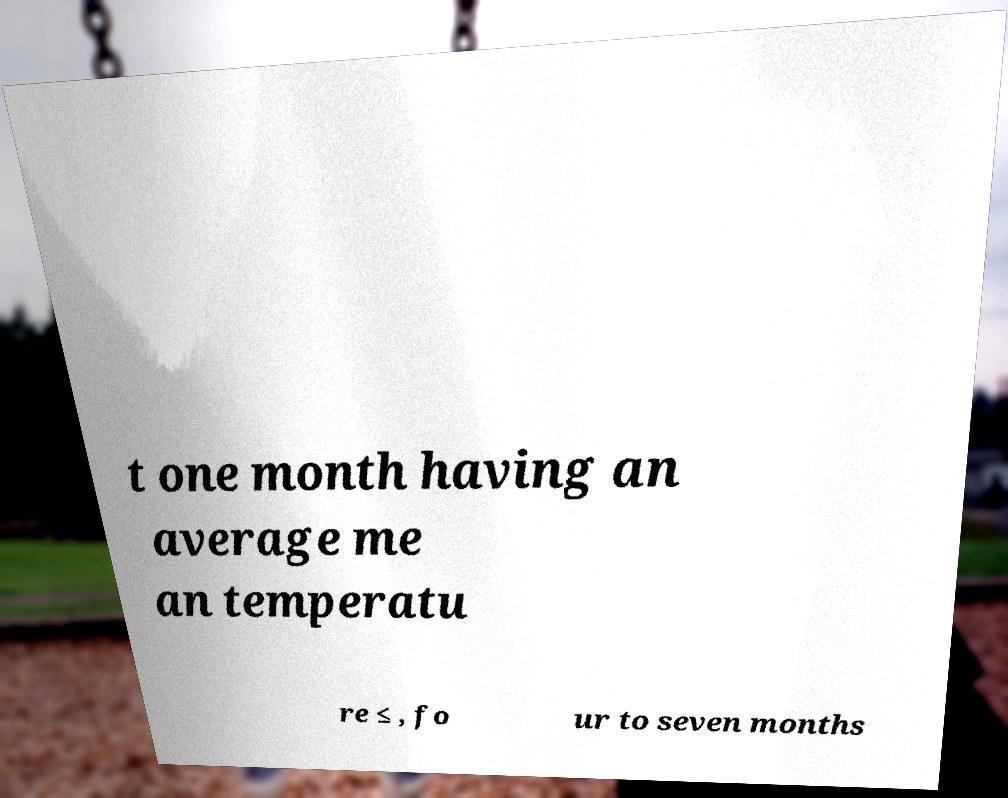Could you extract and type out the text from this image? t one month having an average me an temperatu re ≤ , fo ur to seven months 